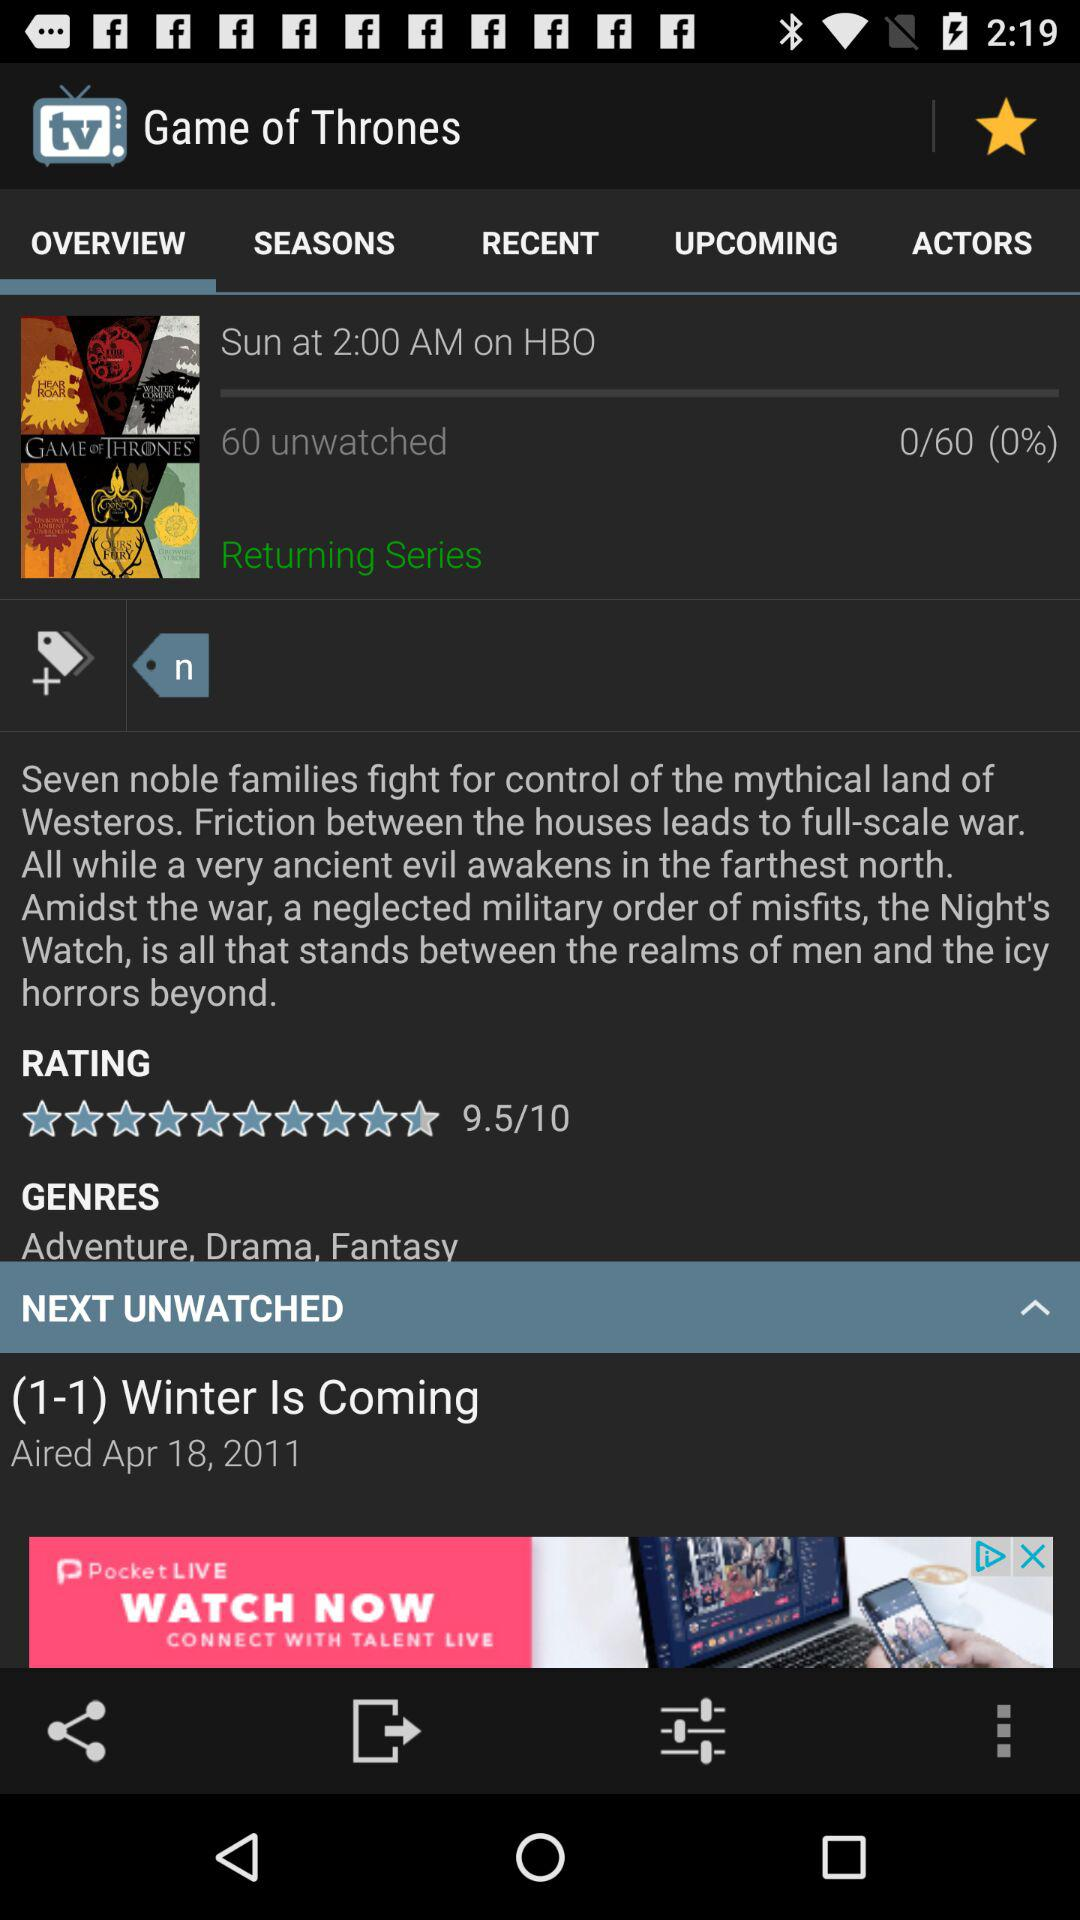Which tab is currently selected? The currently selected tab is "OVERVIEW". 